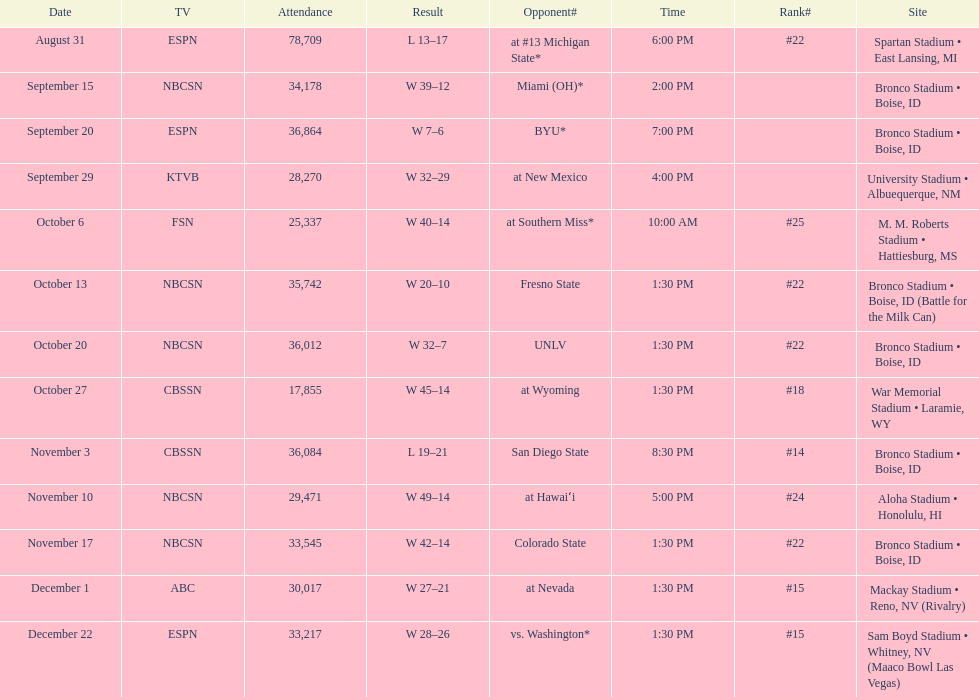Help me parse the entirety of this table. {'header': ['Date', 'TV', 'Attendance', 'Result', 'Opponent#', 'Time', 'Rank#', 'Site'], 'rows': [['August 31', 'ESPN', '78,709', 'L\xa013–17', 'at\xa0#13\xa0Michigan State*', '6:00 PM', '#22', 'Spartan Stadium • East Lansing, MI'], ['September 15', 'NBCSN', '34,178', 'W\xa039–12', 'Miami (OH)*', '2:00 PM', '', 'Bronco Stadium • Boise, ID'], ['September 20', 'ESPN', '36,864', 'W\xa07–6', 'BYU*', '7:00 PM', '', 'Bronco Stadium • Boise, ID'], ['September 29', 'KTVB', '28,270', 'W\xa032–29', 'at\xa0New Mexico', '4:00 PM', '', 'University Stadium • Albuequerque, NM'], ['October 6', 'FSN', '25,337', 'W\xa040–14', 'at\xa0Southern Miss*', '10:00 AM', '#25', 'M. M. Roberts Stadium • Hattiesburg, MS'], ['October 13', 'NBCSN', '35,742', 'W\xa020–10', 'Fresno State', '1:30 PM', '#22', 'Bronco Stadium • Boise, ID (Battle for the Milk Can)'], ['October 20', 'NBCSN', '36,012', 'W\xa032–7', 'UNLV', '1:30 PM', '#22', 'Bronco Stadium • Boise, ID'], ['October 27', 'CBSSN', '17,855', 'W\xa045–14', 'at\xa0Wyoming', '1:30 PM', '#18', 'War Memorial Stadium • Laramie, WY'], ['November 3', 'CBSSN', '36,084', 'L\xa019–21', 'San Diego State', '8:30 PM', '#14', 'Bronco Stadium • Boise, ID'], ['November 10', 'NBCSN', '29,471', 'W\xa049–14', 'at\xa0Hawaiʻi', '5:00 PM', '#24', 'Aloha Stadium • Honolulu, HI'], ['November 17', 'NBCSN', '33,545', 'W\xa042–14', 'Colorado State', '1:30 PM', '#22', 'Bronco Stadium • Boise, ID'], ['December 1', 'ABC', '30,017', 'W\xa027–21', 'at\xa0Nevada', '1:30 PM', '#15', 'Mackay Stadium • Reno, NV (Rivalry)'], ['December 22', 'ESPN', '33,217', 'W\xa028–26', 'vs.\xa0Washington*', '1:30 PM', '#15', 'Sam Boyd Stadium • Whitney, NV (Maaco Bowl Las Vegas)']]} What was there top ranked position of the season? #14. 